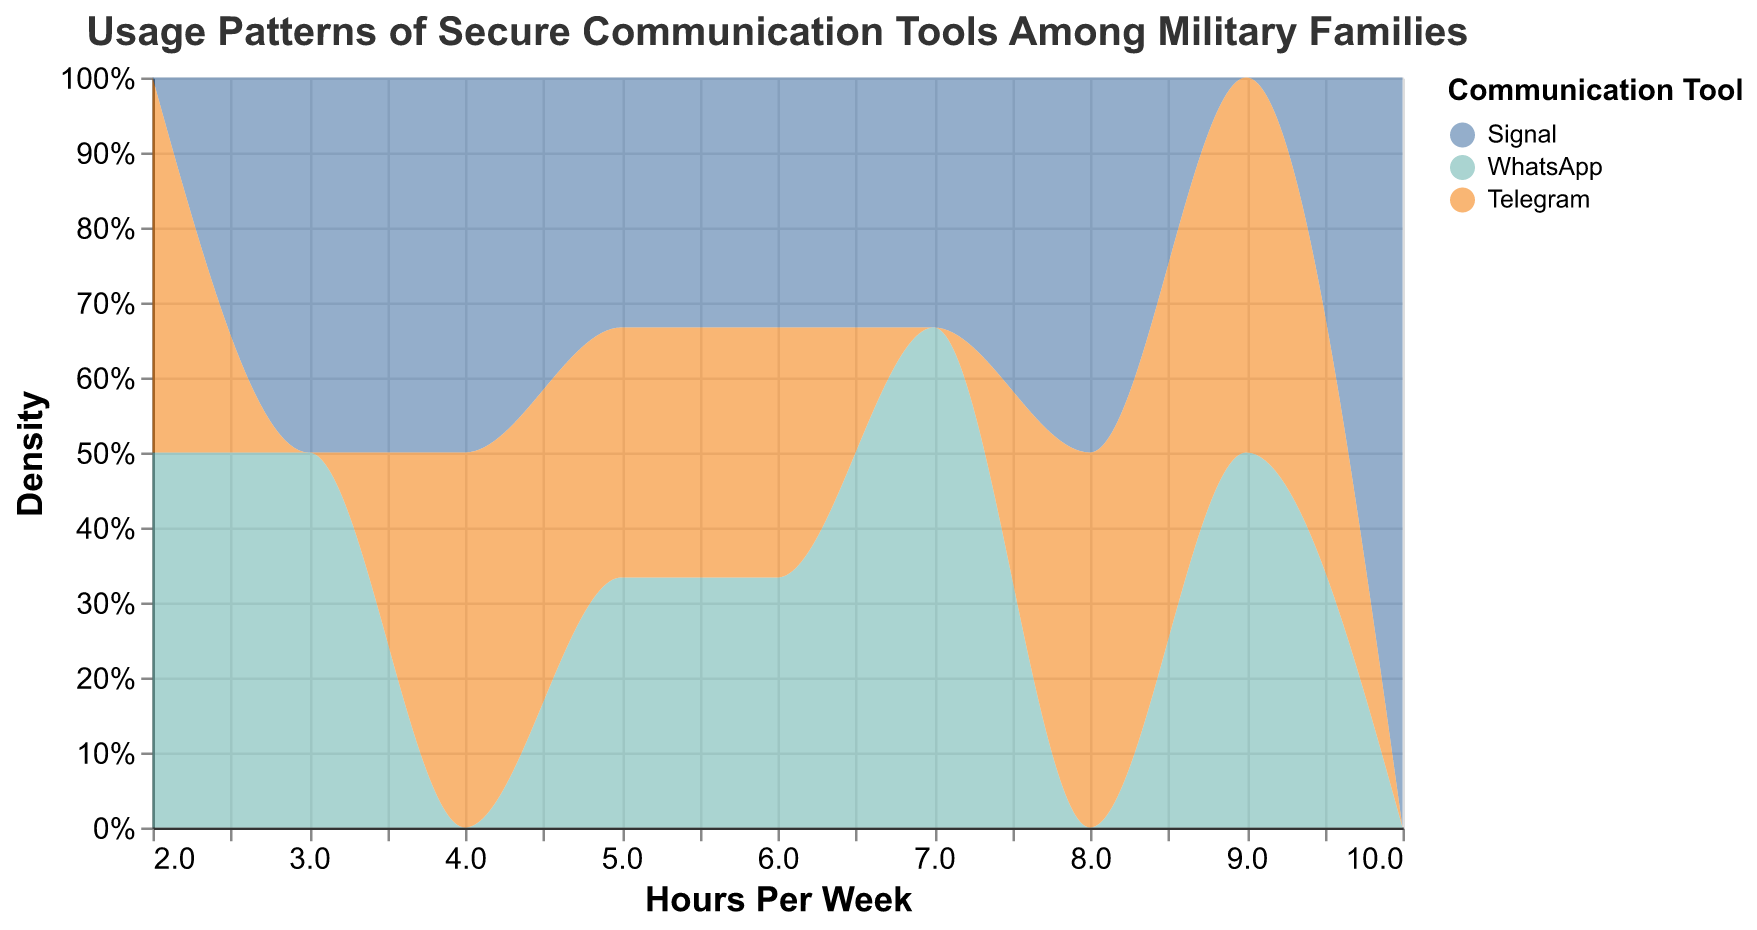What is the title of the plot? The title of the plot is displayed at the top and represents the main topic of the figure.
Answer: Usage Patterns of Secure Communication Tools Among Military Families What are the different communication tools shown in the plot? The plot uses different colors to represent each communication tool, which are indicated in the legend.
Answer: Signal, WhatsApp, Telegram What is the x-axis representing in the plot? The x-axis represents the number of hours spent per week using each communication tool.
Answer: Hours Per Week Which tool has the highest density around 4 hours per week? By observing the density plot, we see higher density for a particular tool near the 4-hour mark.
Answer: Signal Which tool shows the broadest range of usage hours? A broad range indicates the tool is used across a wide span of hours per week.
Answer: Signal Comparing Signal and WhatsApp, which tool has a higher peak density of usage hours? By looking at the peaks of the density curves, we can compare their highest points.
Answer: Signal What does the y-axis represent in this plot? The y-axis represents the density, normalized by the count of data points for different usage hours.
Answer: Density At what hours per week does Telegram show noticeable density? Observing the plot, identify the hours where the density for Telegram is visible.
Answer: Approximately 2 to 9 hours per week Which tool has the most consistent usage pattern across different hours per week? Consistency would be indicated by a more uniform density distribution across the x-axis.
Answer: WhatsApp What is the aggregate function used for the y-axis in the plot? The y-axis uses an aggregate function to show data density.
Answer: Count 